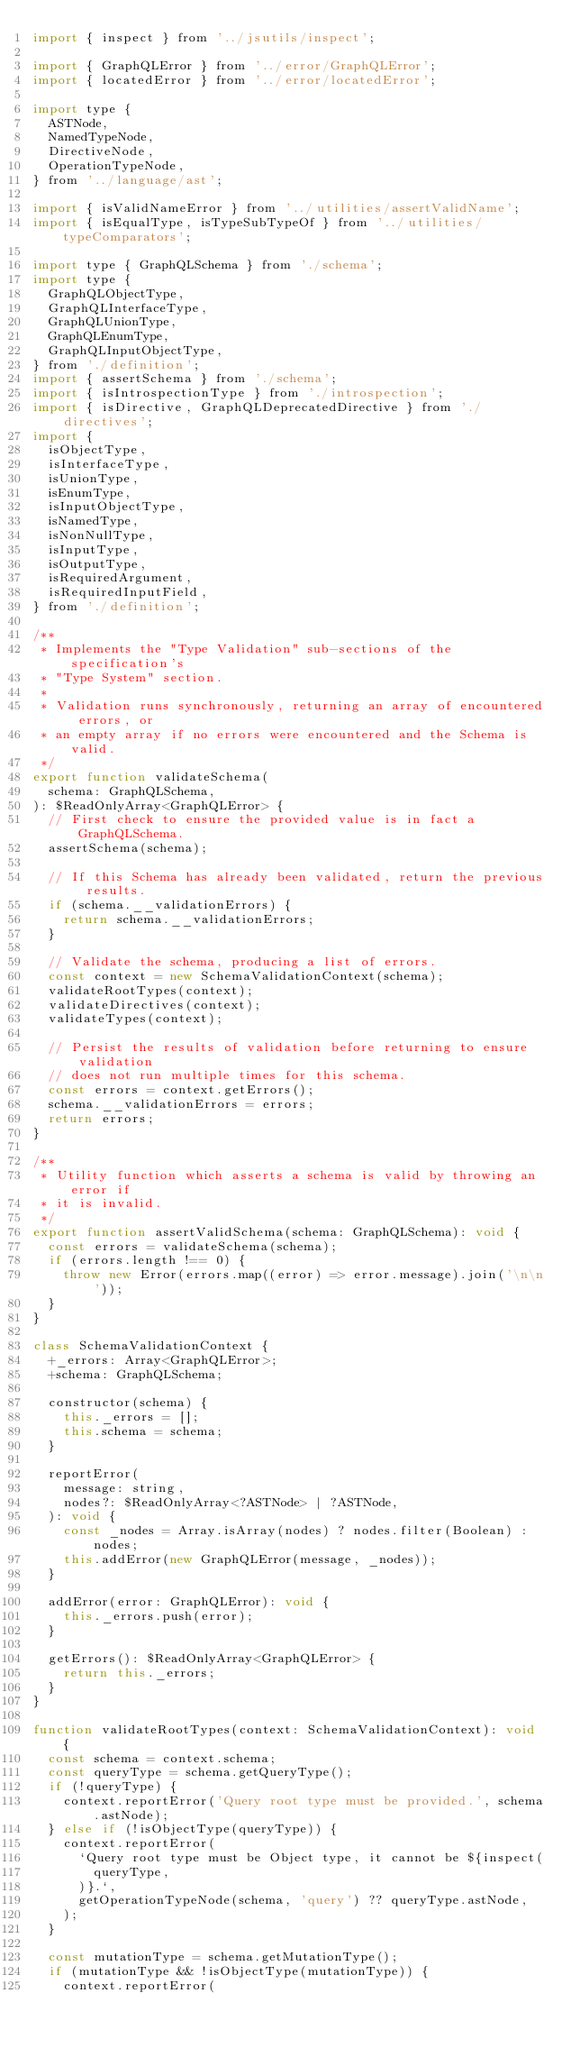<code> <loc_0><loc_0><loc_500><loc_500><_JavaScript_>import { inspect } from '../jsutils/inspect';

import { GraphQLError } from '../error/GraphQLError';
import { locatedError } from '../error/locatedError';

import type {
  ASTNode,
  NamedTypeNode,
  DirectiveNode,
  OperationTypeNode,
} from '../language/ast';

import { isValidNameError } from '../utilities/assertValidName';
import { isEqualType, isTypeSubTypeOf } from '../utilities/typeComparators';

import type { GraphQLSchema } from './schema';
import type {
  GraphQLObjectType,
  GraphQLInterfaceType,
  GraphQLUnionType,
  GraphQLEnumType,
  GraphQLInputObjectType,
} from './definition';
import { assertSchema } from './schema';
import { isIntrospectionType } from './introspection';
import { isDirective, GraphQLDeprecatedDirective } from './directives';
import {
  isObjectType,
  isInterfaceType,
  isUnionType,
  isEnumType,
  isInputObjectType,
  isNamedType,
  isNonNullType,
  isInputType,
  isOutputType,
  isRequiredArgument,
  isRequiredInputField,
} from './definition';

/**
 * Implements the "Type Validation" sub-sections of the specification's
 * "Type System" section.
 *
 * Validation runs synchronously, returning an array of encountered errors, or
 * an empty array if no errors were encountered and the Schema is valid.
 */
export function validateSchema(
  schema: GraphQLSchema,
): $ReadOnlyArray<GraphQLError> {
  // First check to ensure the provided value is in fact a GraphQLSchema.
  assertSchema(schema);

  // If this Schema has already been validated, return the previous results.
  if (schema.__validationErrors) {
    return schema.__validationErrors;
  }

  // Validate the schema, producing a list of errors.
  const context = new SchemaValidationContext(schema);
  validateRootTypes(context);
  validateDirectives(context);
  validateTypes(context);

  // Persist the results of validation before returning to ensure validation
  // does not run multiple times for this schema.
  const errors = context.getErrors();
  schema.__validationErrors = errors;
  return errors;
}

/**
 * Utility function which asserts a schema is valid by throwing an error if
 * it is invalid.
 */
export function assertValidSchema(schema: GraphQLSchema): void {
  const errors = validateSchema(schema);
  if (errors.length !== 0) {
    throw new Error(errors.map((error) => error.message).join('\n\n'));
  }
}

class SchemaValidationContext {
  +_errors: Array<GraphQLError>;
  +schema: GraphQLSchema;

  constructor(schema) {
    this._errors = [];
    this.schema = schema;
  }

  reportError(
    message: string,
    nodes?: $ReadOnlyArray<?ASTNode> | ?ASTNode,
  ): void {
    const _nodes = Array.isArray(nodes) ? nodes.filter(Boolean) : nodes;
    this.addError(new GraphQLError(message, _nodes));
  }

  addError(error: GraphQLError): void {
    this._errors.push(error);
  }

  getErrors(): $ReadOnlyArray<GraphQLError> {
    return this._errors;
  }
}

function validateRootTypes(context: SchemaValidationContext): void {
  const schema = context.schema;
  const queryType = schema.getQueryType();
  if (!queryType) {
    context.reportError('Query root type must be provided.', schema.astNode);
  } else if (!isObjectType(queryType)) {
    context.reportError(
      `Query root type must be Object type, it cannot be ${inspect(
        queryType,
      )}.`,
      getOperationTypeNode(schema, 'query') ?? queryType.astNode,
    );
  }

  const mutationType = schema.getMutationType();
  if (mutationType && !isObjectType(mutationType)) {
    context.reportError(</code> 